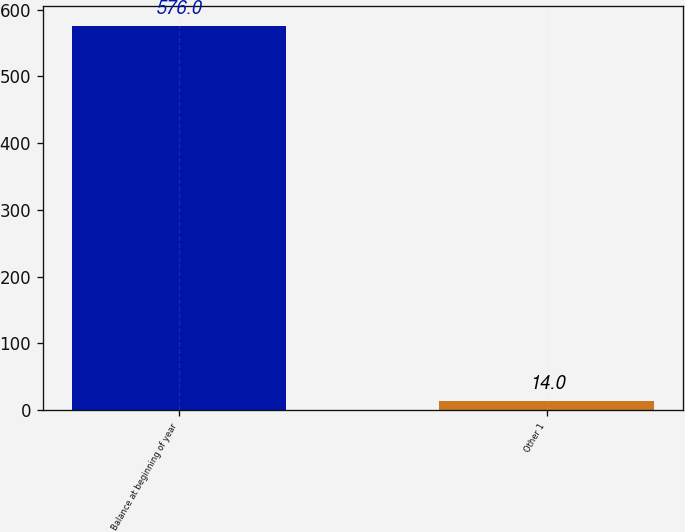Convert chart. <chart><loc_0><loc_0><loc_500><loc_500><bar_chart><fcel>Balance at beginning of year<fcel>Other 1<nl><fcel>576<fcel>14<nl></chart> 